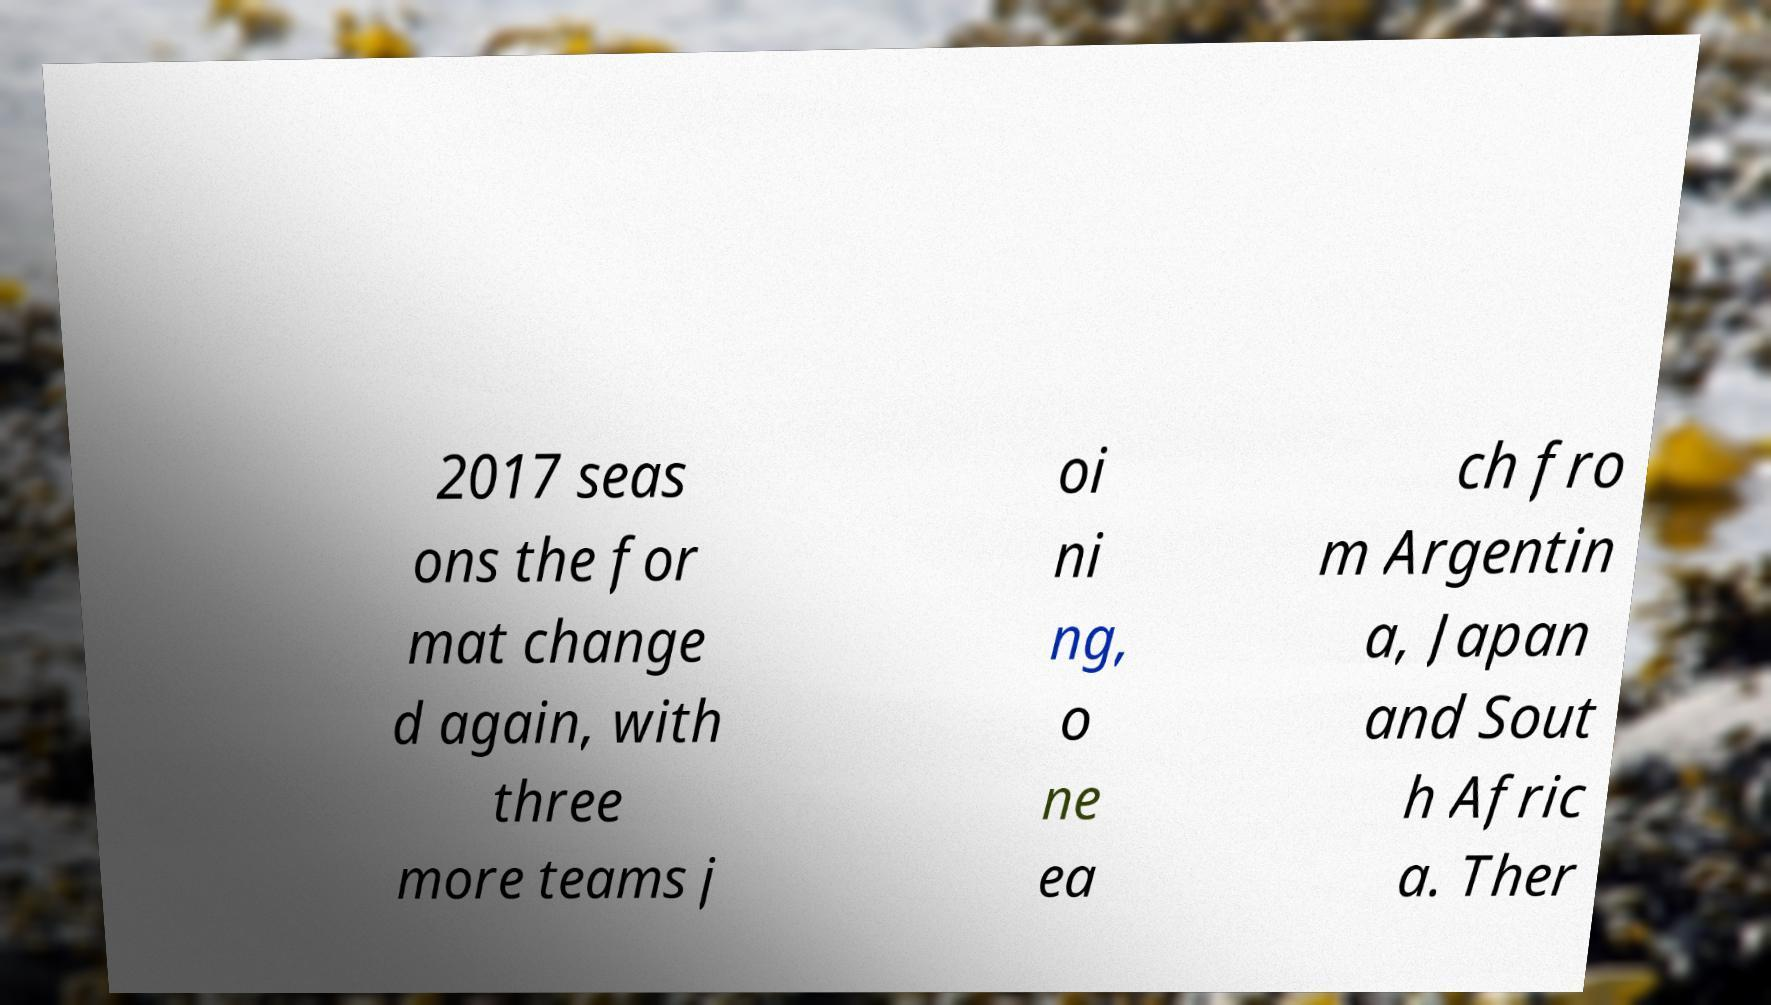Can you accurately transcribe the text from the provided image for me? 2017 seas ons the for mat change d again, with three more teams j oi ni ng, o ne ea ch fro m Argentin a, Japan and Sout h Afric a. Ther 